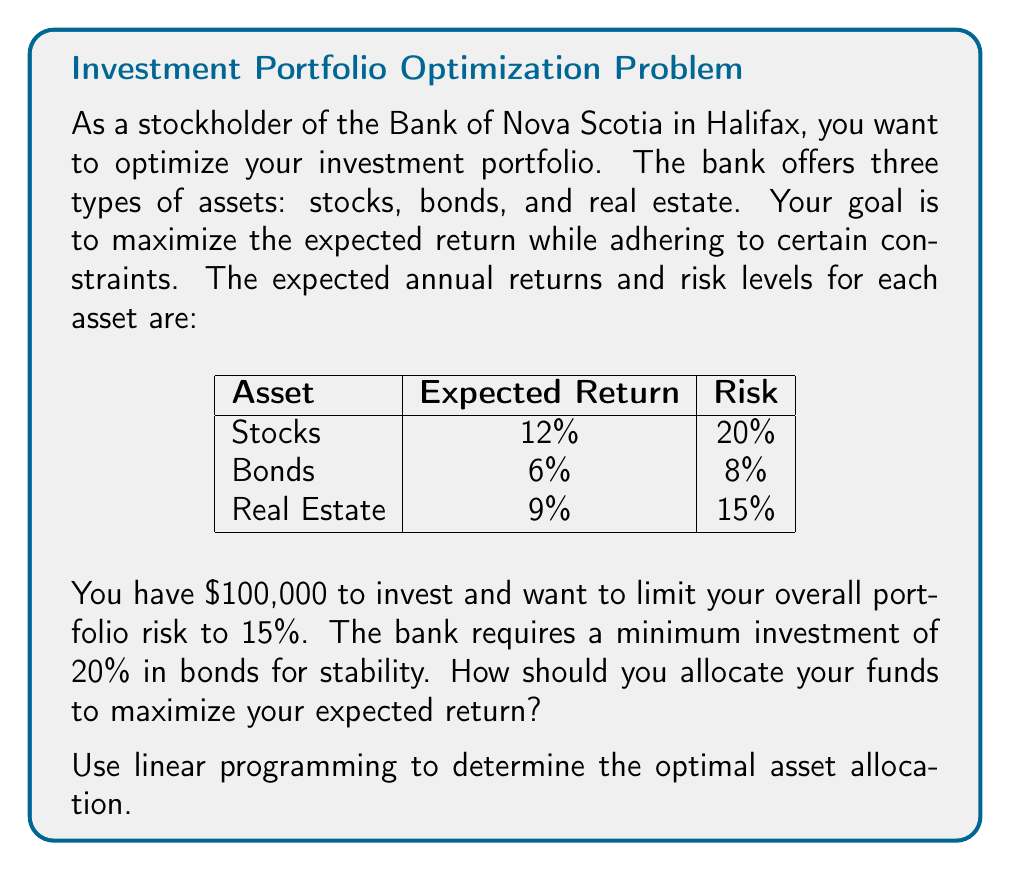Can you answer this question? Let's solve this problem using linear programming:

1. Define variables:
   Let $x_1$, $x_2$, and $x_3$ be the fractions of the portfolio invested in stocks, bonds, and real estate, respectively.

2. Objective function:
   Maximize expected return: $$ Z = 0.12x_1 + 0.06x_2 + 0.09x_3 $$

3. Constraints:
   a) Total allocation: $$ x_1 + x_2 + x_3 = 1 $$
   b) Risk limit: $$ 0.20x_1 + 0.08x_2 + 0.15x_3 \leq 0.15 $$
   c) Minimum bond allocation: $$ x_2 \geq 0.20 $$
   d) Non-negativity: $$ x_1, x_2, x_3 \geq 0 $$

4. Solve using the simplex method or linear programming software:
   The optimal solution is:
   $x_1 = 0.3125$ (31.25% in stocks)
   $x_2 = 0.2000$ (20.00% in bonds)
   $x_3 = 0.4875$ (48.75% in real estate)

5. Verify constraints:
   a) $0.3125 + 0.2000 + 0.4875 = 1$
   b) $0.20(0.3125) + 0.08(0.2000) + 0.15(0.4875) = 0.15$
   c) $0.2000 \geq 0.20$

6. Calculate expected return:
   $Z = 0.12(0.3125) + 0.06(0.2000) + 0.09(0.4875) = 0.09375$ or 9.375%

Therefore, the optimal asset allocation that maximizes return while meeting all constraints is 31.25% in stocks, 20% in bonds, and 48.75% in real estate, yielding an expected return of 9.375%.
Answer: Stocks: 31.25%, Bonds: 20%, Real Estate: 48.75% 